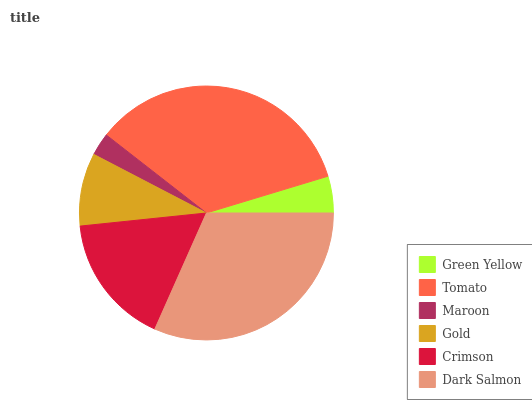Is Maroon the minimum?
Answer yes or no. Yes. Is Tomato the maximum?
Answer yes or no. Yes. Is Tomato the minimum?
Answer yes or no. No. Is Maroon the maximum?
Answer yes or no. No. Is Tomato greater than Maroon?
Answer yes or no. Yes. Is Maroon less than Tomato?
Answer yes or no. Yes. Is Maroon greater than Tomato?
Answer yes or no. No. Is Tomato less than Maroon?
Answer yes or no. No. Is Crimson the high median?
Answer yes or no. Yes. Is Gold the low median?
Answer yes or no. Yes. Is Tomato the high median?
Answer yes or no. No. Is Green Yellow the low median?
Answer yes or no. No. 